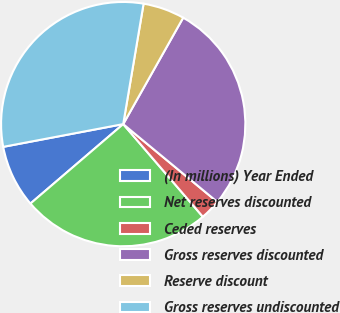<chart> <loc_0><loc_0><loc_500><loc_500><pie_chart><fcel>(In millions) Year Ended<fcel>Net reserves discounted<fcel>Ceded reserves<fcel>Gross reserves discounted<fcel>Reserve discount<fcel>Gross reserves undiscounted<nl><fcel>8.29%<fcel>25.03%<fcel>2.7%<fcel>27.83%<fcel>5.5%<fcel>30.65%<nl></chart> 